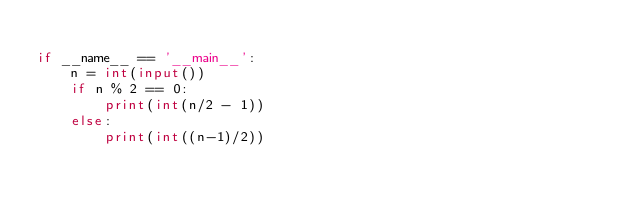<code> <loc_0><loc_0><loc_500><loc_500><_Python_>
if __name__ == '__main__':
    n = int(input())
    if n % 2 == 0:
        print(int(n/2 - 1))
    else:
        print(int((n-1)/2))</code> 